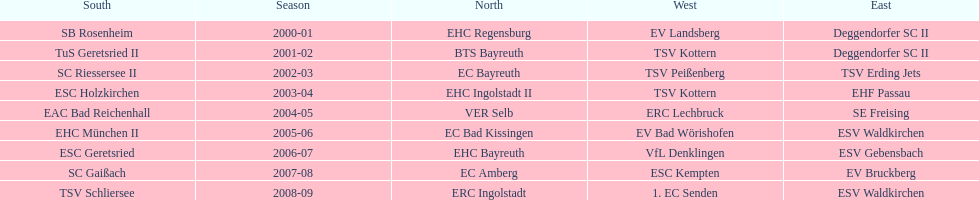Would you be able to parse every entry in this table? {'header': ['South', 'Season', 'North', 'West', 'East'], 'rows': [['SB Rosenheim', '2000-01', 'EHC Regensburg', 'EV Landsberg', 'Deggendorfer SC II'], ['TuS Geretsried II', '2001-02', 'BTS Bayreuth', 'TSV Kottern', 'Deggendorfer SC II'], ['SC Riessersee II', '2002-03', 'EC Bayreuth', 'TSV Peißenberg', 'TSV Erding Jets'], ['ESC Holzkirchen', '2003-04', 'EHC Ingolstadt II', 'TSV Kottern', 'EHF Passau'], ['EAC Bad Reichenhall', '2004-05', 'VER Selb', 'ERC Lechbruck', 'SE Freising'], ['EHC München II', '2005-06', 'EC Bad Kissingen', 'EV Bad Wörishofen', 'ESV Waldkirchen'], ['ESC Geretsried', '2006-07', 'EHC Bayreuth', 'VfL Denklingen', 'ESV Gebensbach'], ['SC Gaißach', '2007-08', 'EC Amberg', 'ESC Kempten', 'EV Bruckberg'], ['TSV Schliersee', '2008-09', 'ERC Ingolstadt', '1. EC Senden', 'ESV Waldkirchen']]} The last team to win the west? 1. EC Senden. 